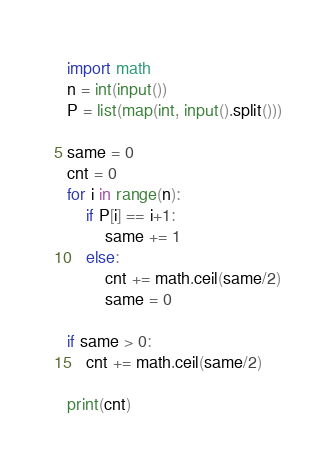Convert code to text. <code><loc_0><loc_0><loc_500><loc_500><_Python_>import math
n = int(input())
P = list(map(int, input().split()))

same = 0
cnt = 0
for i in range(n):
    if P[i] == i+1:
        same += 1
    else:
        cnt += math.ceil(same/2)
        same = 0

if same > 0:
    cnt += math.ceil(same/2)

print(cnt)</code> 